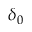<formula> <loc_0><loc_0><loc_500><loc_500>\delta _ { 0 }</formula> 